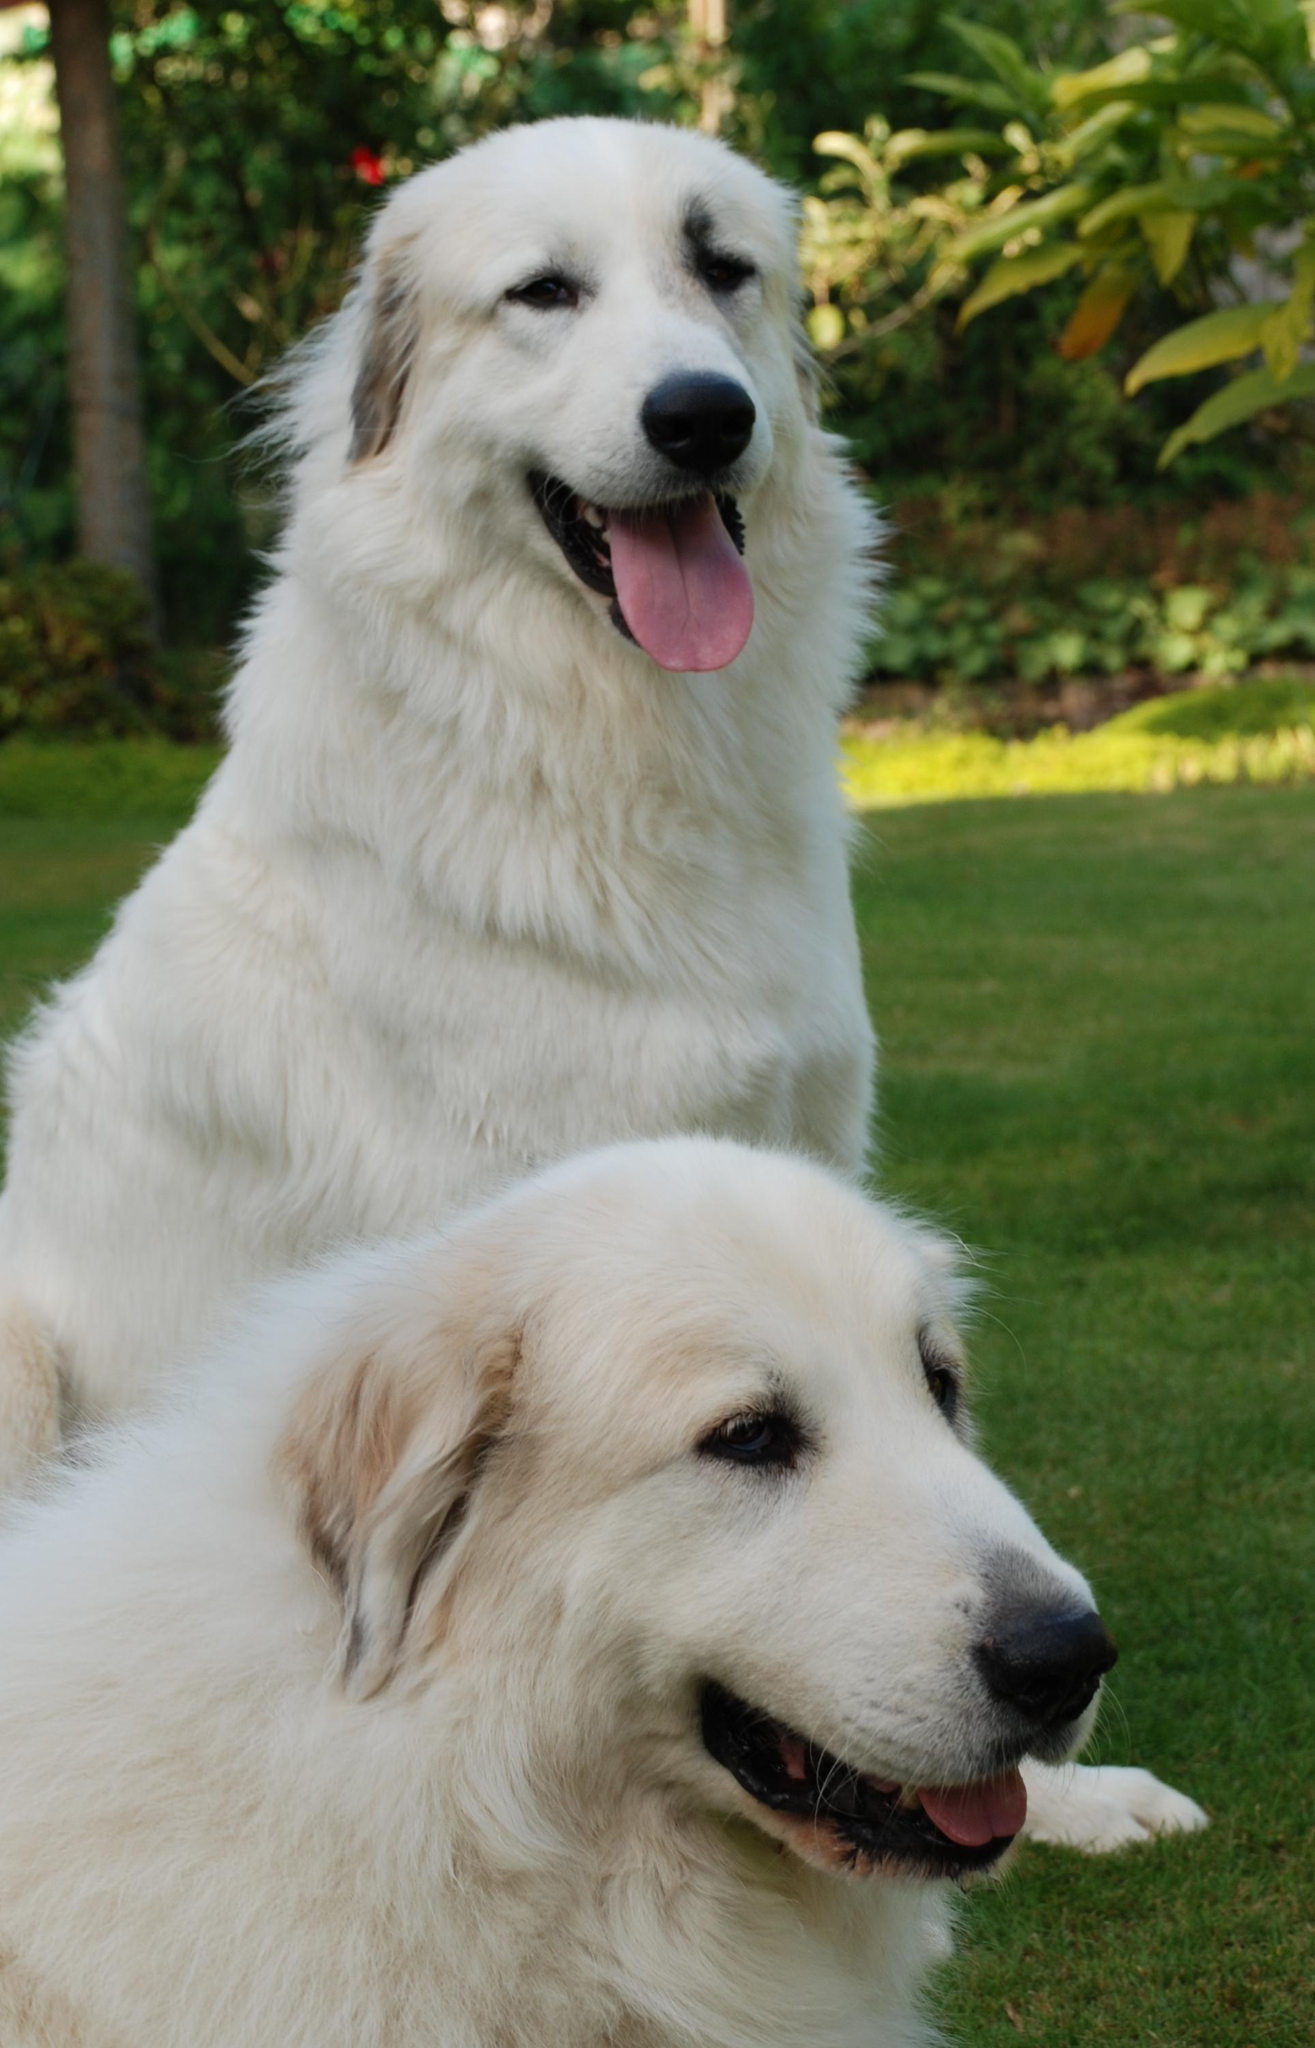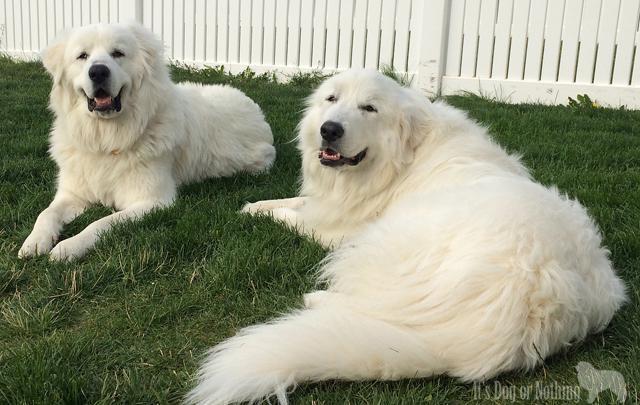The first image is the image on the left, the second image is the image on the right. Considering the images on both sides, is "In total, only two fluffy dogs can be seen in these images." valid? Answer yes or no. No. The first image is the image on the left, the second image is the image on the right. For the images shown, is this caption "There are two dogs" true? Answer yes or no. No. 